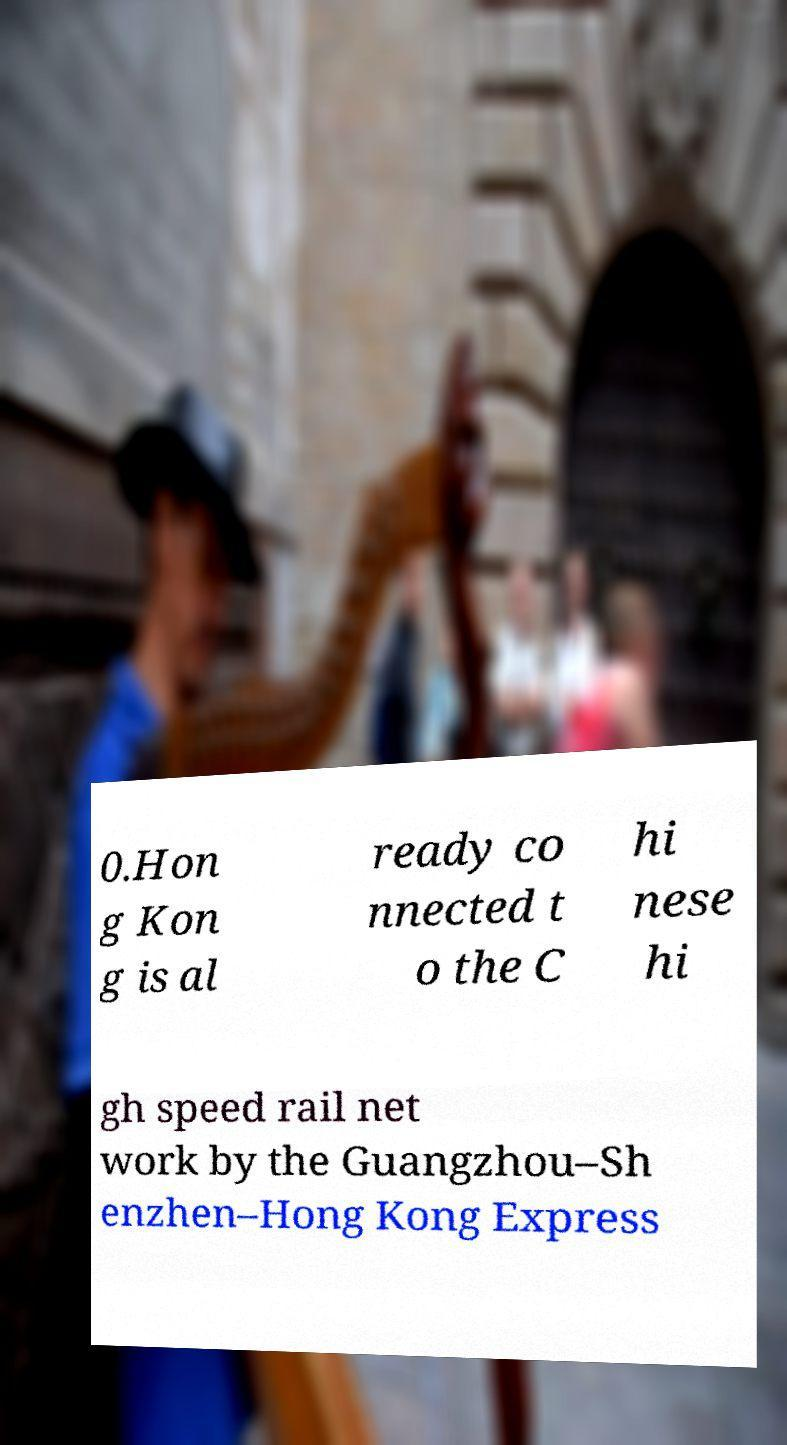Could you extract and type out the text from this image? 0.Hon g Kon g is al ready co nnected t o the C hi nese hi gh speed rail net work by the Guangzhou–Sh enzhen–Hong Kong Express 